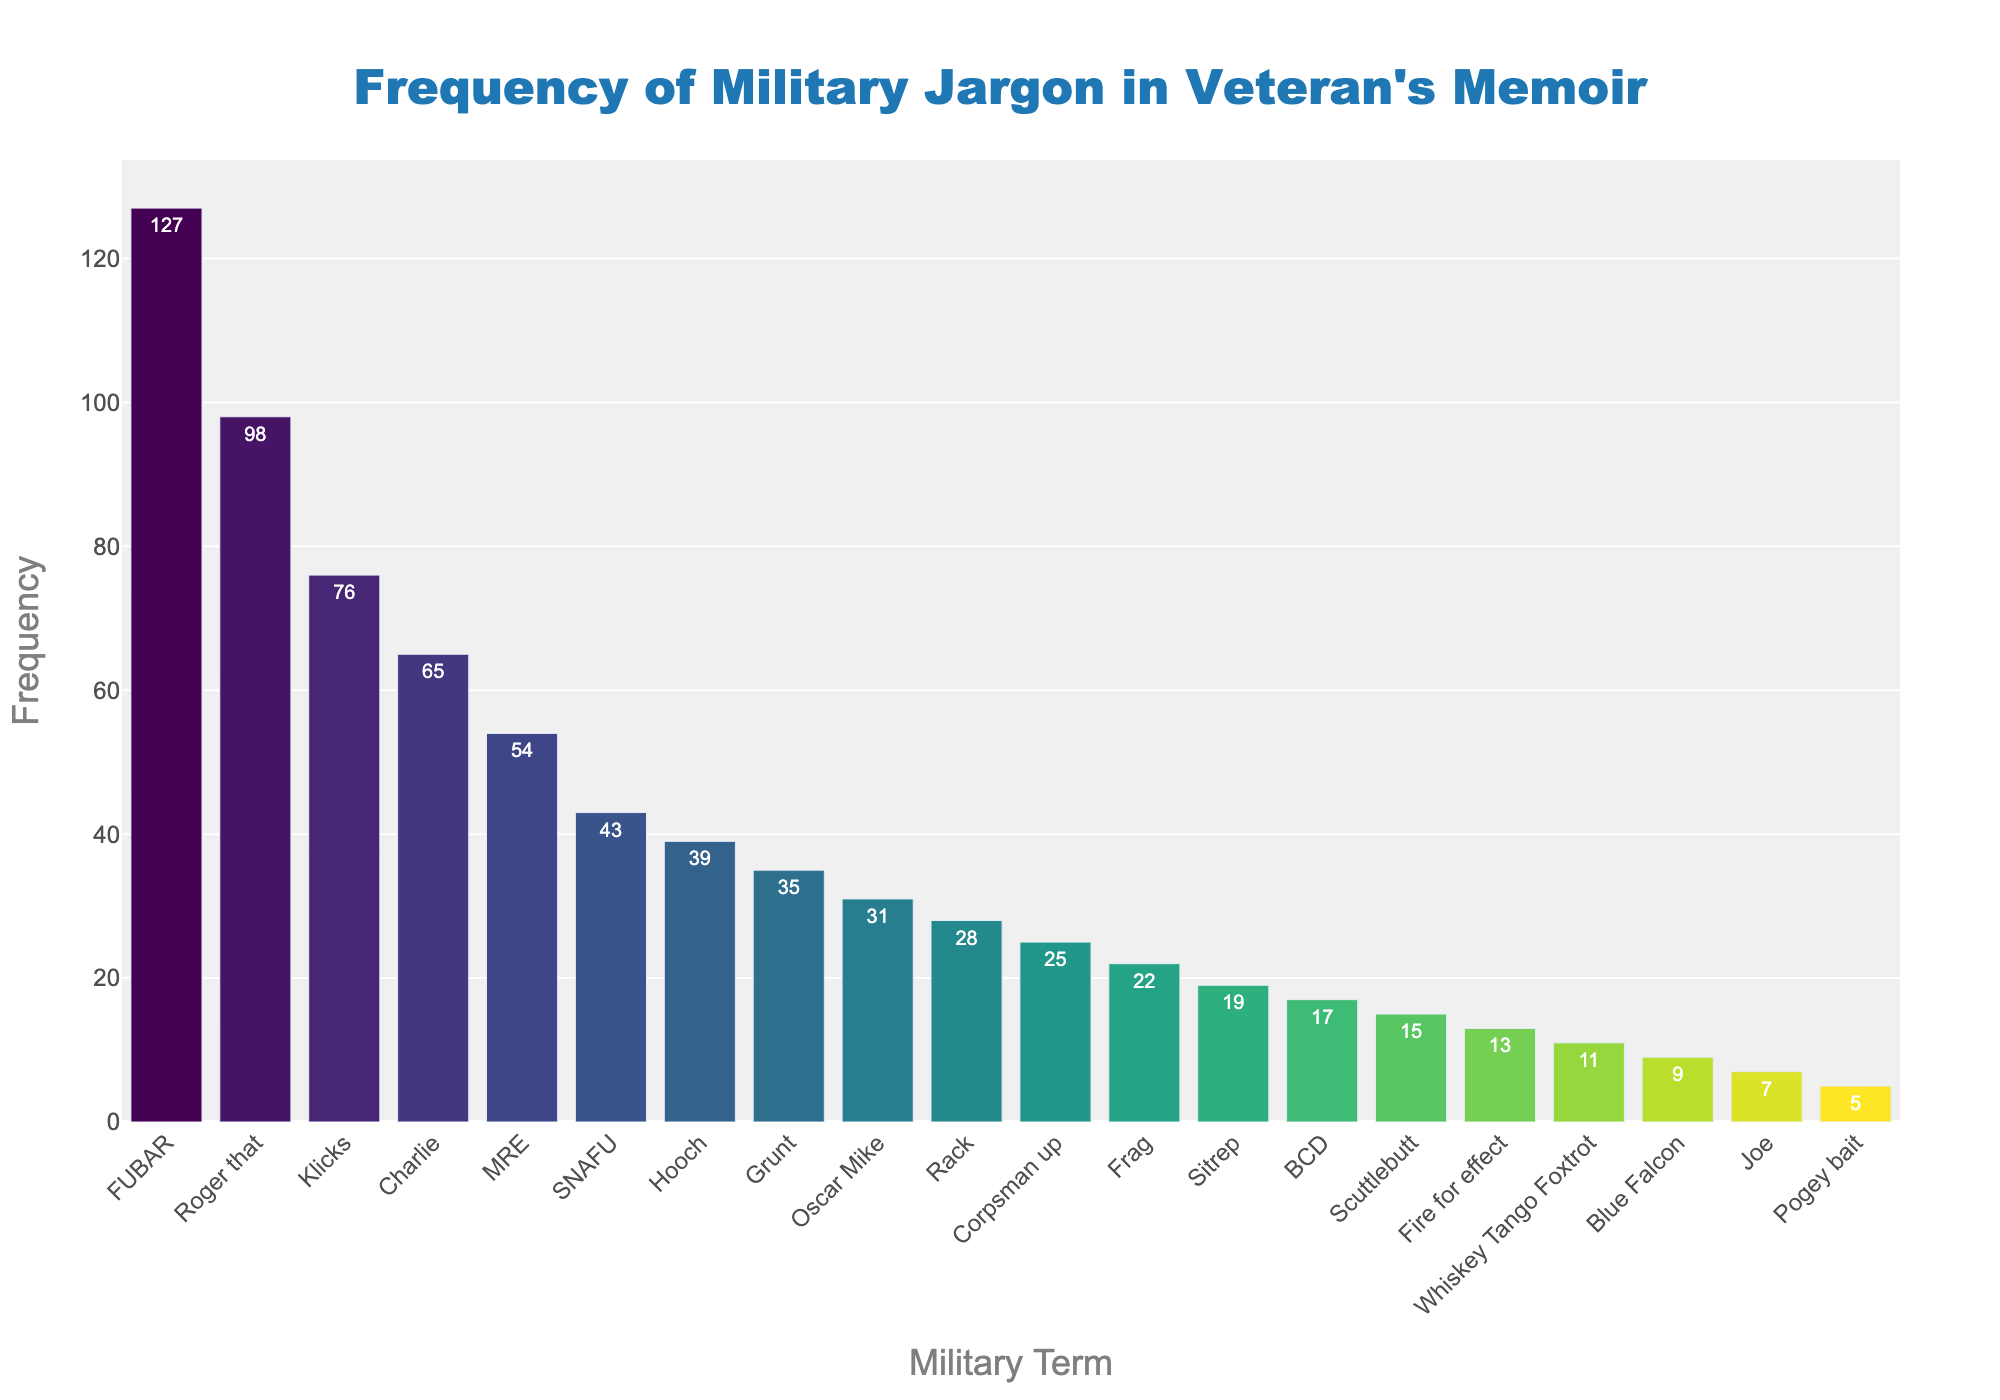Which term has the highest usage frequency? The bar corresponding to the term 'FUBAR' is the tallest, indicating it has the highest frequency among all the terms.
Answer: FUBAR How many more times is 'Roger that' used than 'Rack'? 'Roger that' has a frequency of 98 and 'Rack' has a frequency of 28. The difference is 98 - 28 = 70.
Answer: 70 Which term has the lowest frequency? The shortest bar corresponds to the term 'Pogey bait', indicating it has the lowest frequency among the terms.
Answer: Pogey bait What is the combined frequency of 'Grunt' and 'Oscar Mike'? 'Grunt' has a frequency of 35 and 'Oscar Mike' has a frequency of 31. The combined frequency is 35 + 31 = 66.
Answer: 66 Is 'Charlie' used more frequently than 'MRE'? The bar for 'Charlie' is taller than the bar for 'MRE', indicating 'Charlie' has a higher frequency.
Answer: Yes What is the median frequency among all the terms? The sorted frequency list is 5, 7, 9, 11, 13, 15, 17, 19, 22, 25, 28, 31, 35, 39, 43, 54, 65, 76, 98, 127. The median value, being the average of the 10th and 11th values, is (25 + 28) / 2 = 26.5.
Answer: 26.5 How does the frequency of 'SNAFU' compare to 'Hooch'? The bar for 'SNAFU' is slightly higher than the bar for 'Hooch', suggesting 'SNAFU' is used more frequently.
Answer: More Are there more terms with a frequency above 50 or below 50? Terms with frequencies above 50: FUBAR, Roger that, Klicks, Charlie, MRE (5 terms). Terms with frequencies below 50: SNAFU, Hooch, Grunt, Oscar Mike, Rack, Corpsman up, Frag, Sitrep, BCD, Scuttlebutt, Fire for effect, Whiskey Tango Foxtrot, Blue Falcon, Joe, Pogey bait (15 terms).
Answer: Below 50 What is the average frequency of the top 5 most frequently used terms? The top 5 terms are FUBAR (127), Roger that (98), Klicks (76), Charlie (65), MRE (54). The average is (127 + 98 + 76 + 65 + 54) / 5 = 84.
Answer: 84 